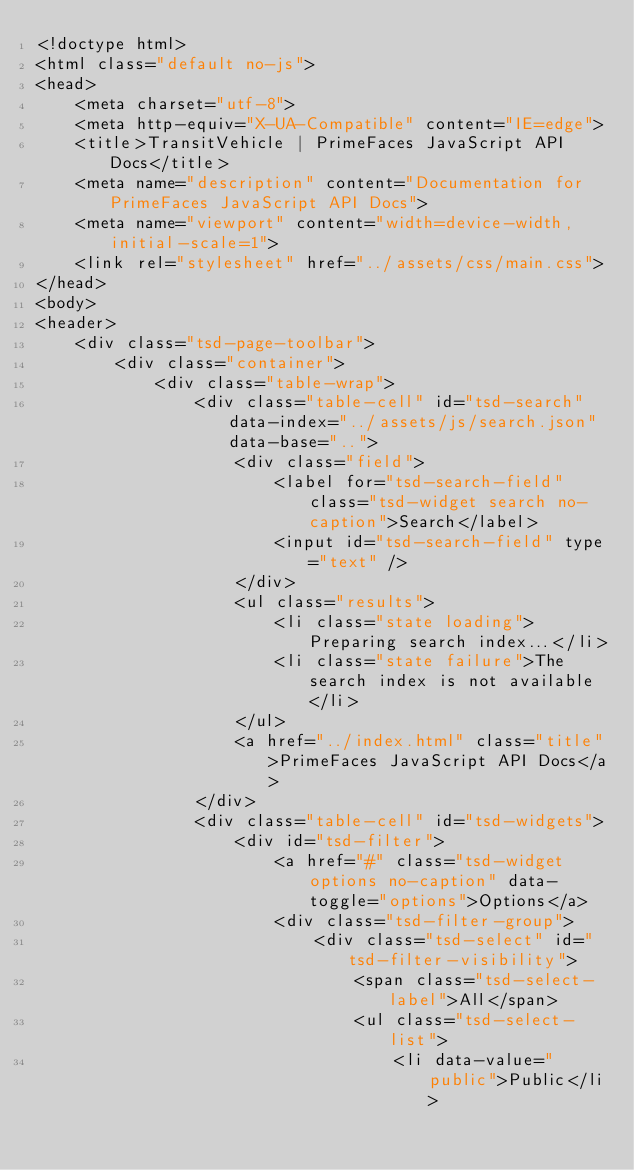<code> <loc_0><loc_0><loc_500><loc_500><_HTML_><!doctype html>
<html class="default no-js">
<head>
	<meta charset="utf-8">
	<meta http-equiv="X-UA-Compatible" content="IE=edge">
	<title>TransitVehicle | PrimeFaces JavaScript API Docs</title>
	<meta name="description" content="Documentation for PrimeFaces JavaScript API Docs">
	<meta name="viewport" content="width=device-width, initial-scale=1">
	<link rel="stylesheet" href="../assets/css/main.css">
</head>
<body>
<header>
	<div class="tsd-page-toolbar">
		<div class="container">
			<div class="table-wrap">
				<div class="table-cell" id="tsd-search" data-index="../assets/js/search.json" data-base="..">
					<div class="field">
						<label for="tsd-search-field" class="tsd-widget search no-caption">Search</label>
						<input id="tsd-search-field" type="text" />
					</div>
					<ul class="results">
						<li class="state loading">Preparing search index...</li>
						<li class="state failure">The search index is not available</li>
					</ul>
					<a href="../index.html" class="title">PrimeFaces JavaScript API Docs</a>
				</div>
				<div class="table-cell" id="tsd-widgets">
					<div id="tsd-filter">
						<a href="#" class="tsd-widget options no-caption" data-toggle="options">Options</a>
						<div class="tsd-filter-group">
							<div class="tsd-select" id="tsd-filter-visibility">
								<span class="tsd-select-label">All</span>
								<ul class="tsd-select-list">
									<li data-value="public">Public</li></code> 